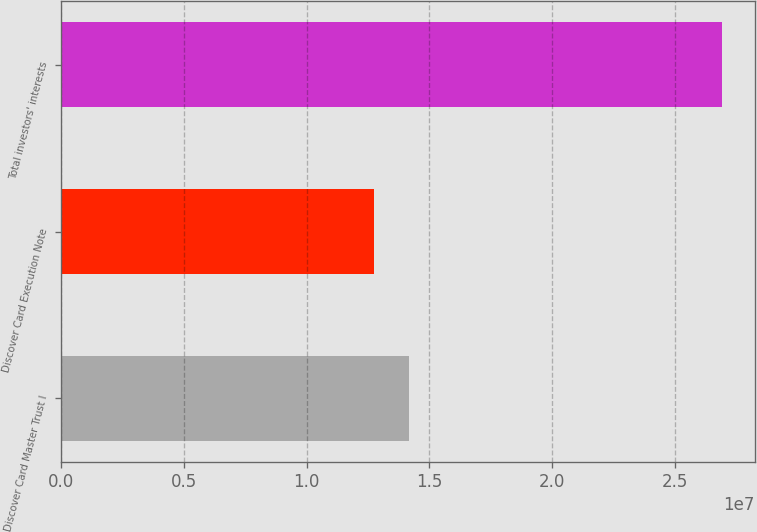Convert chart. <chart><loc_0><loc_0><loc_500><loc_500><bar_chart><fcel>Discover Card Master Trust I<fcel>Discover Card Execution Note<fcel>Total investors' interests<nl><fcel>1.41728e+07<fcel>1.27594e+07<fcel>2.68936e+07<nl></chart> 